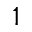Convert formula to latex. <formula><loc_0><loc_0><loc_500><loc_500>1</formula> 